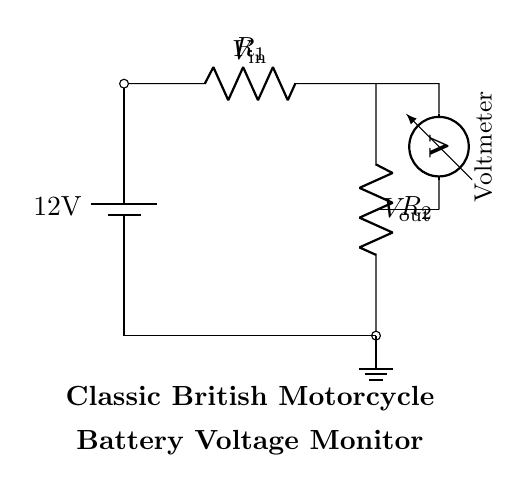What is the input voltage of this circuit? The input voltage is the voltage supplied by the battery, which is labeled as twelve volts in the diagram.
Answer: twelve volts What are the components in this circuit? The components in the circuit include a battery, two resistors, a ground connection, and a voltmeter. The battery provides the voltage, and the resistors form a voltage divider.
Answer: battery, resistors, voltmeter What is the role of the voltmeter in this circuit? The voltmeter measures the output voltage across the second resistor. It is connected in parallel to the resistor and indicates the voltage drop across it.
Answer: measures output voltage What is the relationship between the resistors and the output voltage? The output voltage is proportional to the ratio of resistors R2 and R1 in the voltage divider formula, which states that Vout is equal to Vin times R2 divided by R1 plus R2. This setup allows for adjusting the output based on the resistor values.
Answer: voltage divider ratio How would increasing R1 affect Vout? Increasing R1 would decrease the output voltage, as it increases the total resistance in the voltage divider, causing a smaller fraction of the input voltage to appear across R2 according to the voltage divider rule.
Answer: decreases Vout What would happen if R2 is shorted? If R2 is shorted, the output voltage Vout would drop to zero as all voltage would bypass R2 completely through the short circuit, essentially creating a path of no resistance for the current.
Answer: Vout becomes zero What type of circuit configuration is this? This is a voltage divider circuit configuration, where resistors are arranged in series to divide the input voltage into a lower output voltage.
Answer: voltage divider 